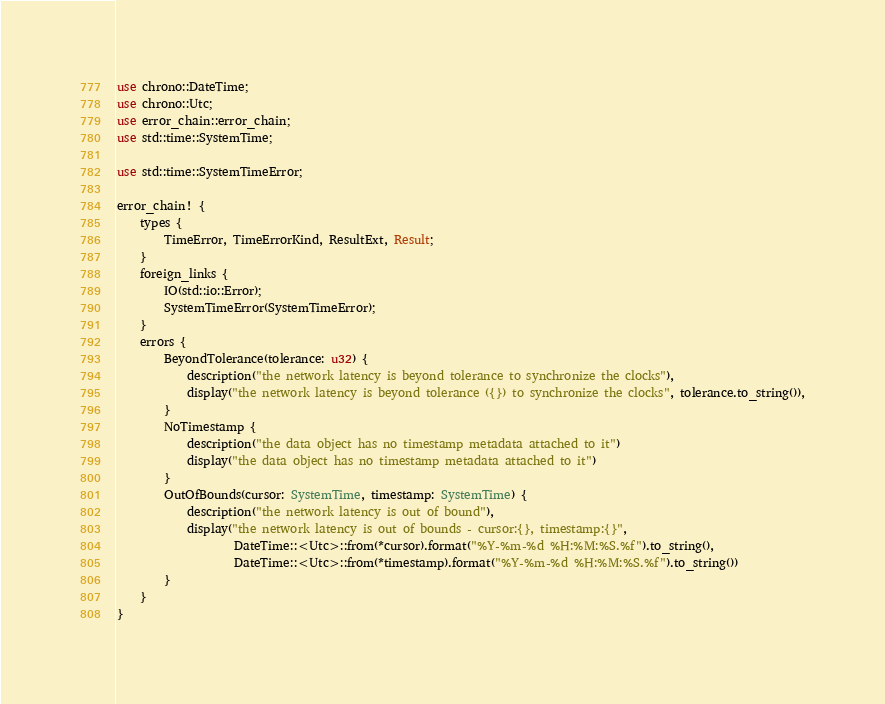<code> <loc_0><loc_0><loc_500><loc_500><_Rust_>use chrono::DateTime;
use chrono::Utc;
use error_chain::error_chain;
use std::time::SystemTime;

use std::time::SystemTimeError;

error_chain! {
    types {
        TimeError, TimeErrorKind, ResultExt, Result;
    }
    foreign_links {
        IO(std::io::Error);
        SystemTimeError(SystemTimeError);
    }
    errors {
        BeyondTolerance(tolerance: u32) {
            description("the network latency is beyond tolerance to synchronize the clocks"),
            display("the network latency is beyond tolerance ({}) to synchronize the clocks", tolerance.to_string()),
        }
        NoTimestamp {
            description("the data object has no timestamp metadata attached to it")
            display("the data object has no timestamp metadata attached to it")
        }
        OutOfBounds(cursor: SystemTime, timestamp: SystemTime) {
            description("the network latency is out of bound"),
            display("the network latency is out of bounds - cursor:{}, timestamp:{}",
                    DateTime::<Utc>::from(*cursor).format("%Y-%m-%d %H:%M:%S.%f").to_string(),
                    DateTime::<Utc>::from(*timestamp).format("%Y-%m-%d %H:%M:%S.%f").to_string())
        }
    }
}
</code> 